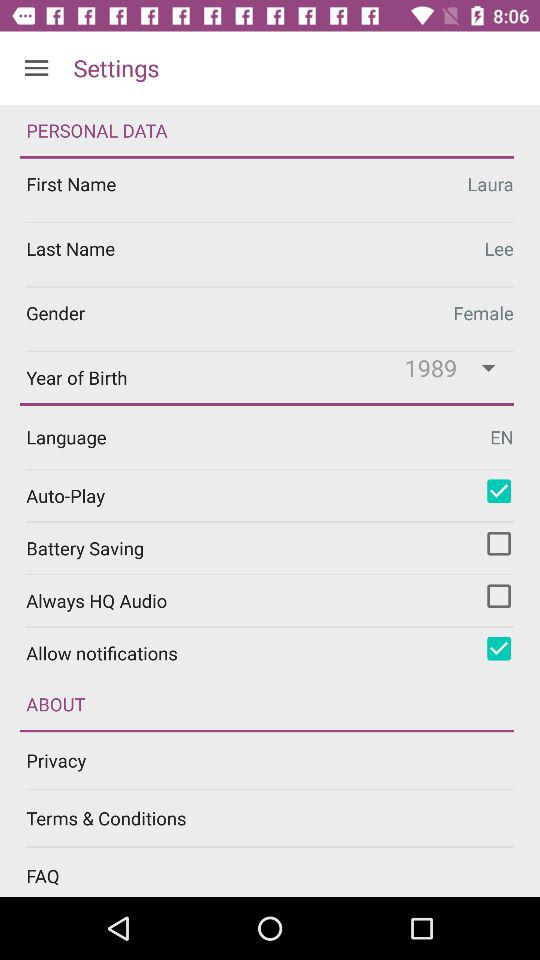What is the last name of the user? The last name of the user is Lee. 